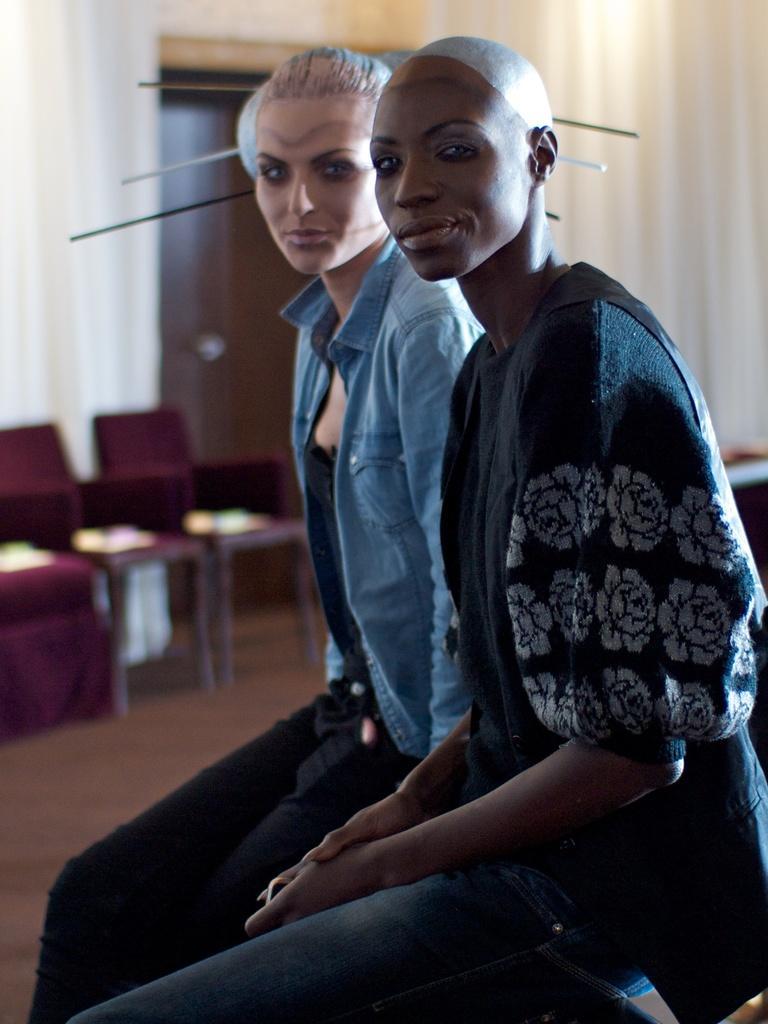Can you describe this image briefly? In the image we can see in front there are two women sitting in front and they are wearing jackets. Behind there are maroon colour chairs kept on the floor. 